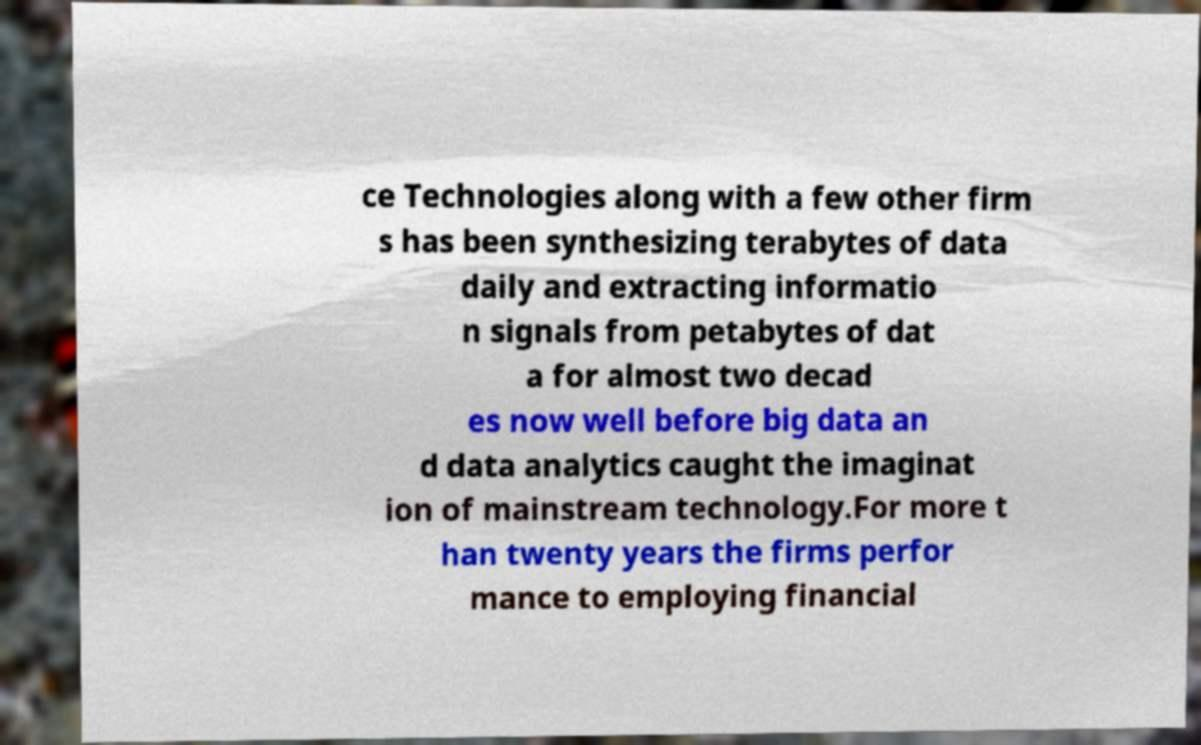There's text embedded in this image that I need extracted. Can you transcribe it verbatim? ce Technologies along with a few other firm s has been synthesizing terabytes of data daily and extracting informatio n signals from petabytes of dat a for almost two decad es now well before big data an d data analytics caught the imaginat ion of mainstream technology.For more t han twenty years the firms perfor mance to employing financial 